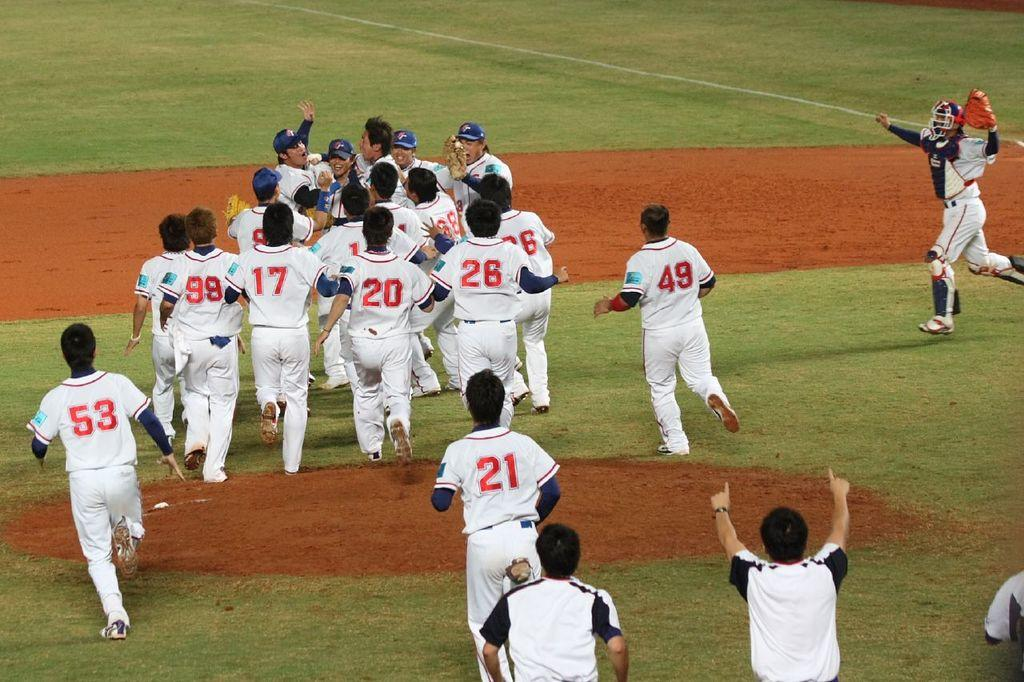<image>
Create a compact narrative representing the image presented. a few people that are celebrating on the field with the number 21 on their jersey 